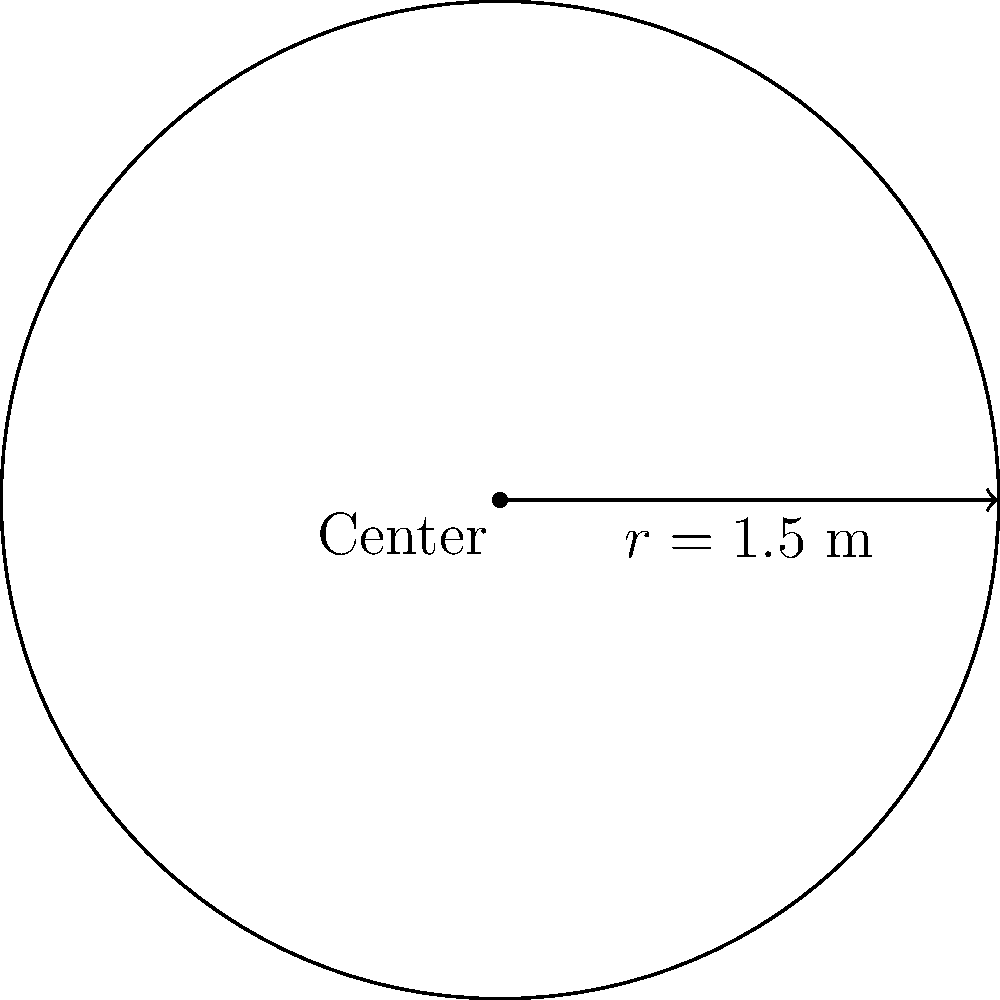For a vegan potluck, you're planning to use a circular dining table. The table has a radius of 1.5 meters. What is the perimeter of the table, which will determine how many people can comfortably sit around it? To find the perimeter of a circular table, we need to calculate its circumference. The formula for the circumference of a circle is:

$$C = 2\pi r$$

Where:
$C$ = circumference (perimeter)
$\pi$ = pi (approximately 3.14159)
$r$ = radius

Given:
$r = 1.5$ meters

Let's substitute these values into the formula:

$$C = 2\pi(1.5)$$

$$C = 3\pi$$

$$C \approx 3(3.14159)$$

$$C \approx 9.42477\text{ meters}$$

Rounding to two decimal places:

$$C \approx 9.42\text{ meters}$$

This means that the perimeter of the table is approximately 9.42 meters, which will determine the space available for seating guests at your vegan potluck.
Answer: $9.42\text{ meters}$ 